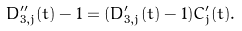<formula> <loc_0><loc_0><loc_500><loc_500>D _ { 3 , j } ^ { \prime \prime } ( t ) - 1 = ( D _ { 3 , j } ^ { \prime } ( t ) - 1 ) C _ { j } ^ { \prime } ( t ) .</formula> 